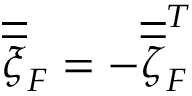Convert formula to latex. <formula><loc_0><loc_0><loc_500><loc_500>\overline { { \overline { \xi } } } _ { \/ F } = - { \overline { { \overline { \zeta } } } } _ { \/ F } ^ { T }</formula> 